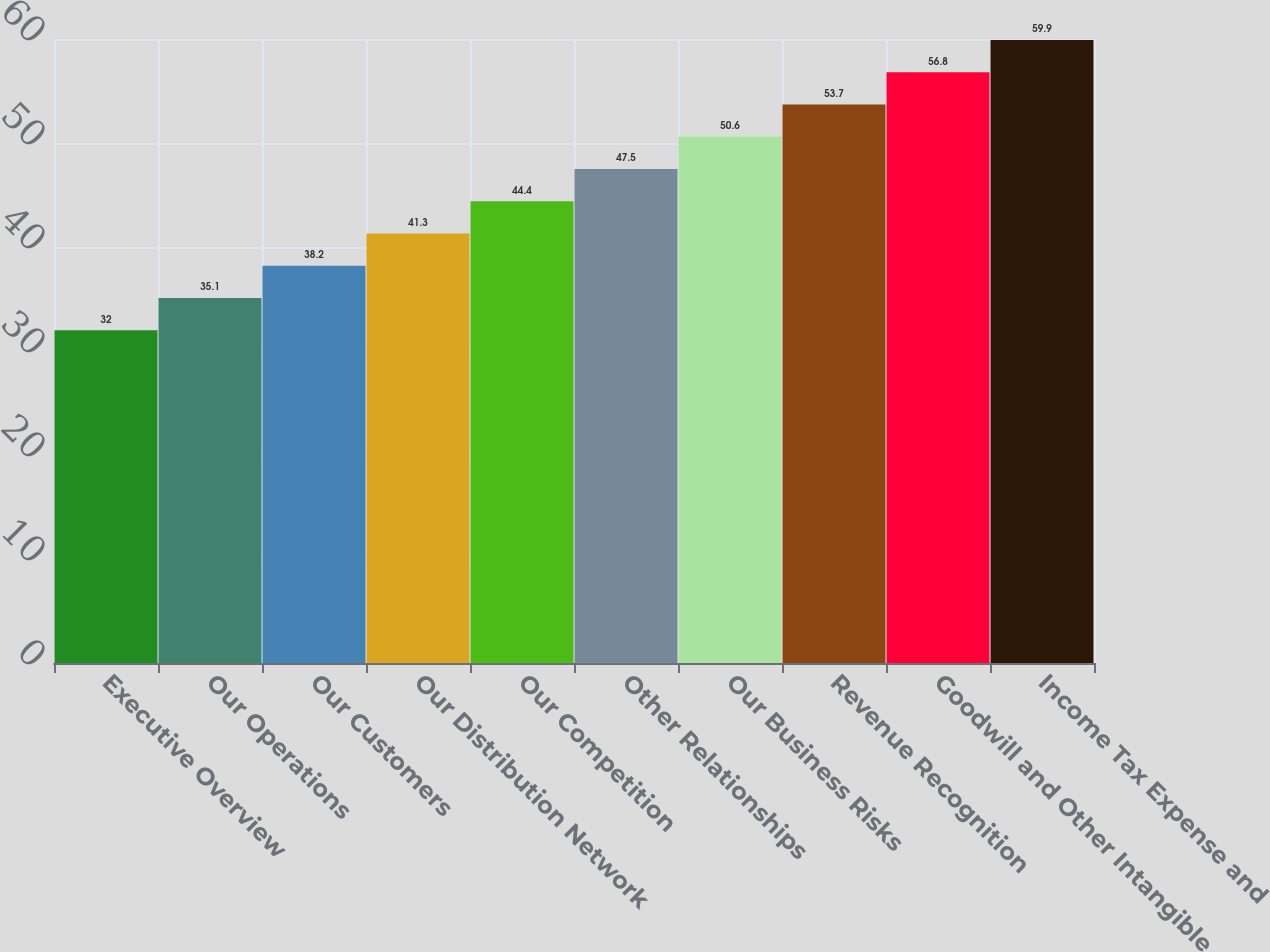<chart> <loc_0><loc_0><loc_500><loc_500><bar_chart><fcel>Executive Overview<fcel>Our Operations<fcel>Our Customers<fcel>Our Distribution Network<fcel>Our Competition<fcel>Other Relationships<fcel>Our Business Risks<fcel>Revenue Recognition<fcel>Goodwill and Other Intangible<fcel>Income Tax Expense and<nl><fcel>32<fcel>35.1<fcel>38.2<fcel>41.3<fcel>44.4<fcel>47.5<fcel>50.6<fcel>53.7<fcel>56.8<fcel>59.9<nl></chart> 